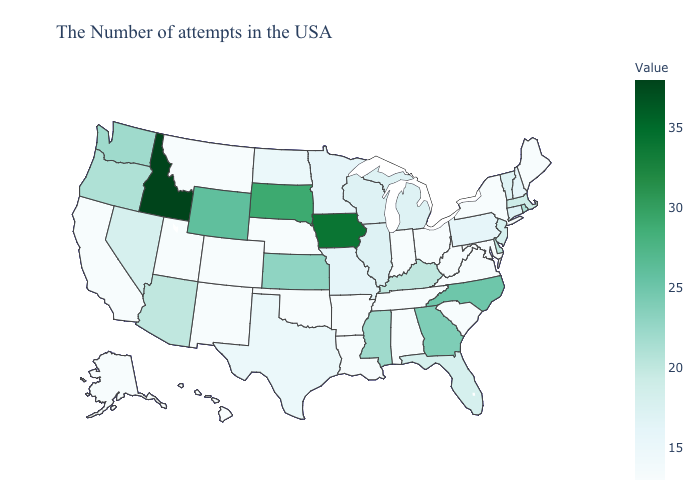Which states have the lowest value in the USA?
Answer briefly. Maine, New York, Maryland, Virginia, South Carolina, West Virginia, Ohio, Indiana, Alabama, Tennessee, Louisiana, Arkansas, Nebraska, Oklahoma, Colorado, New Mexico, Utah, Montana, California, Alaska, Hawaii. Among the states that border Arizona , which have the lowest value?
Short answer required. Colorado, New Mexico, Utah, California. Does Minnesota have the lowest value in the MidWest?
Quick response, please. No. Among the states that border Michigan , does Wisconsin have the highest value?
Give a very brief answer. Yes. 